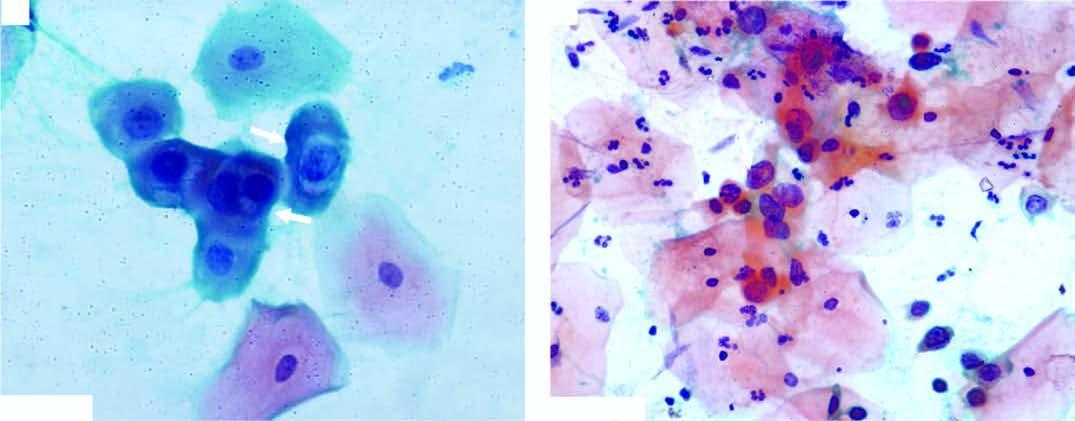what does the smear show?
Answer the question using a single word or phrase. Koilocytes having abundant vacuolated cytoplasm and nuclear enlargement 